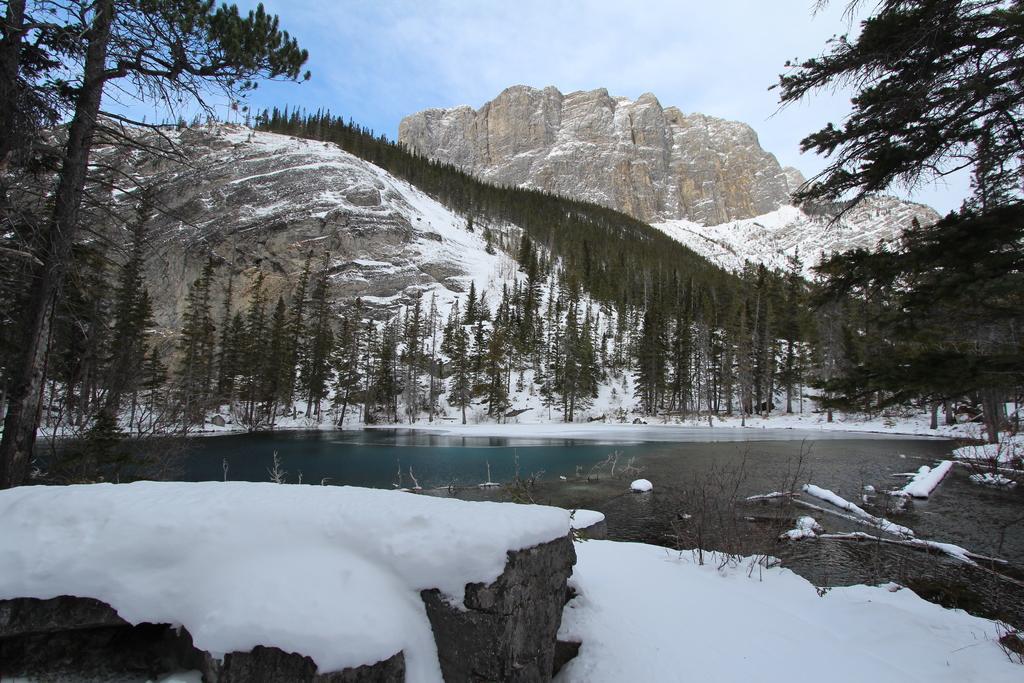Describe this image in one or two sentences. In this image in front there is snow on the surface. At the center there is water. In the background there are trees, mountains and sky. 